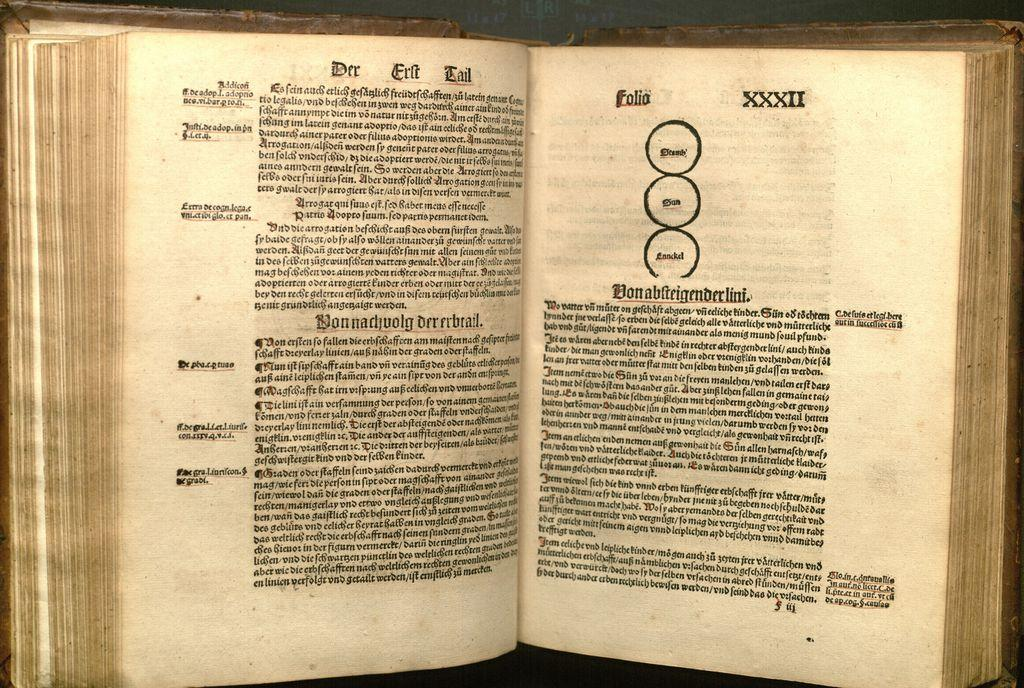<image>
Offer a succinct explanation of the picture presented. A very old book in a foreign language is opened to a page with Folia XXXII at the top. 